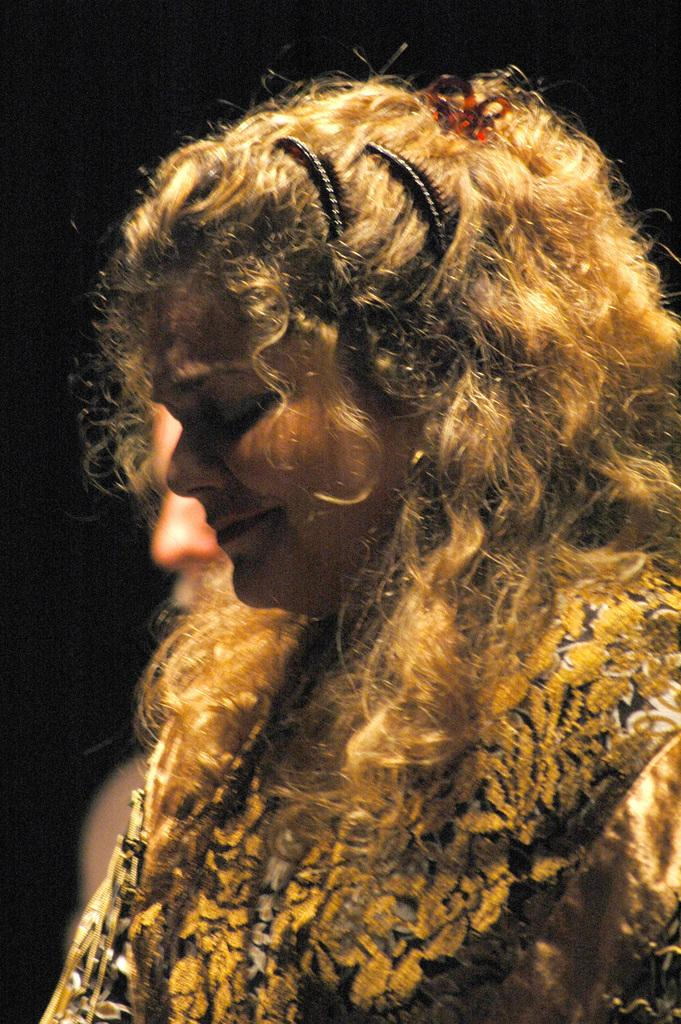Who is the main subject in the image? There is a woman in the center of the image. Can you describe the other person in the image? There is another person beside the woman. What type of religious ceremony is taking place in the image? There is no indication of a religious ceremony in the image; it only shows a woman and another person. What type of vase can be seen on the table in the image? There is no vase present in the image. 